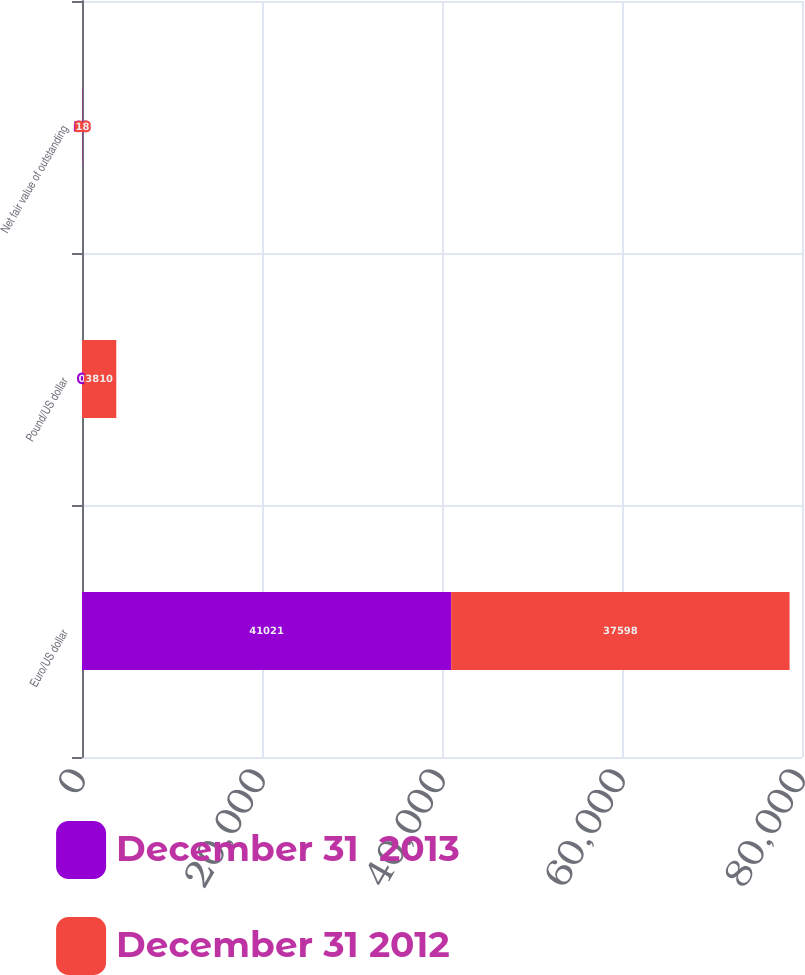Convert chart. <chart><loc_0><loc_0><loc_500><loc_500><stacked_bar_chart><ecel><fcel>Euro/US dollar<fcel>Pound/US dollar<fcel>Net fair value of outstanding<nl><fcel>December 31  2013<fcel>41021<fcel>0<fcel>33<nl><fcel>December 31 2012<fcel>37598<fcel>3810<fcel>18<nl></chart> 